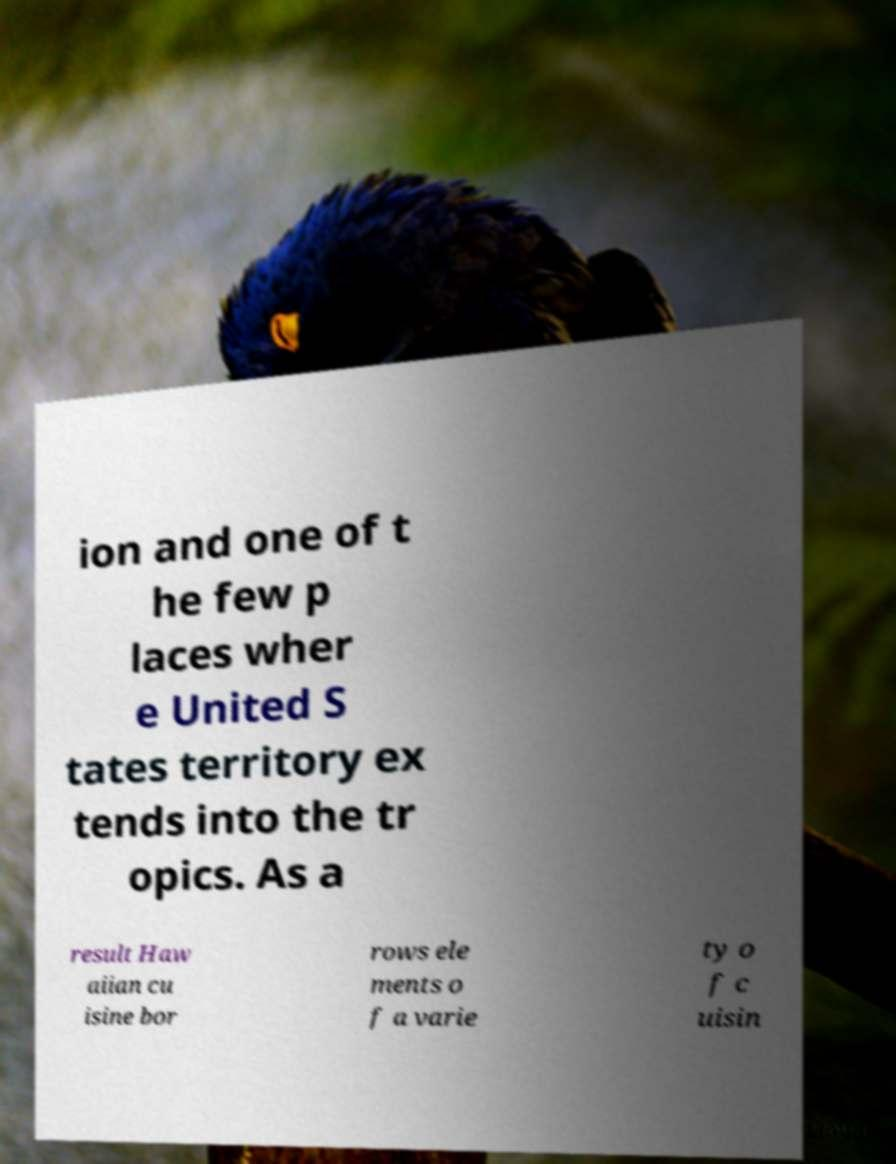Please identify and transcribe the text found in this image. ion and one of t he few p laces wher e United S tates territory ex tends into the tr opics. As a result Haw aiian cu isine bor rows ele ments o f a varie ty o f c uisin 